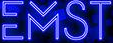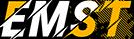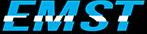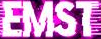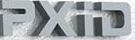What text is displayed in these images sequentially, separated by a semicolon? EMST; EMST; EMST; EMST; PXiD 